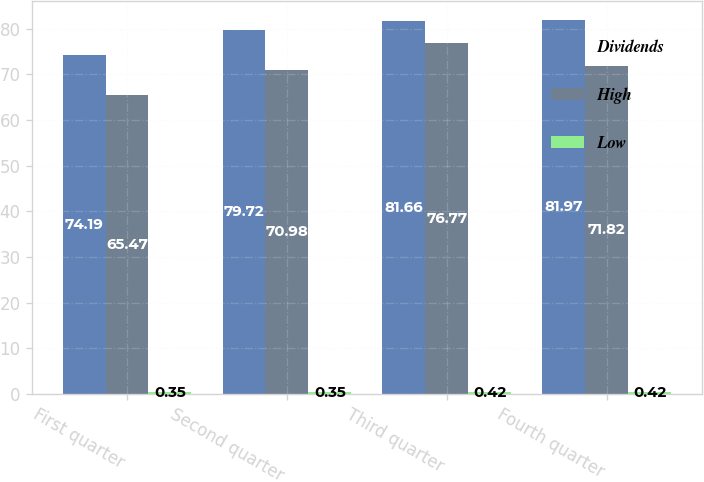<chart> <loc_0><loc_0><loc_500><loc_500><stacked_bar_chart><ecel><fcel>First quarter<fcel>Second quarter<fcel>Third quarter<fcel>Fourth quarter<nl><fcel>Dividends<fcel>74.19<fcel>79.72<fcel>81.66<fcel>81.97<nl><fcel>High<fcel>65.47<fcel>70.98<fcel>76.77<fcel>71.82<nl><fcel>Low<fcel>0.35<fcel>0.35<fcel>0.42<fcel>0.42<nl></chart> 